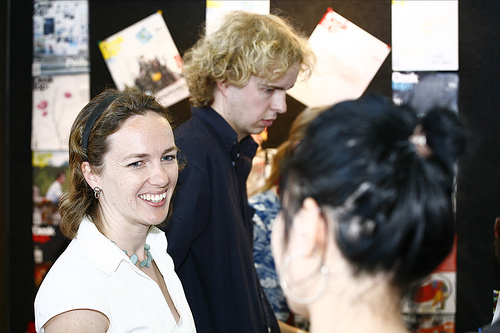<image>
Is the man next to the women? Yes. The man is positioned adjacent to the women, located nearby in the same general area. Is the man next to the women? Yes. The man is positioned adjacent to the women, located nearby in the same general area. Where is the man in relation to the lady? Is it next to the lady? Yes. The man is positioned adjacent to the lady, located nearby in the same general area. 